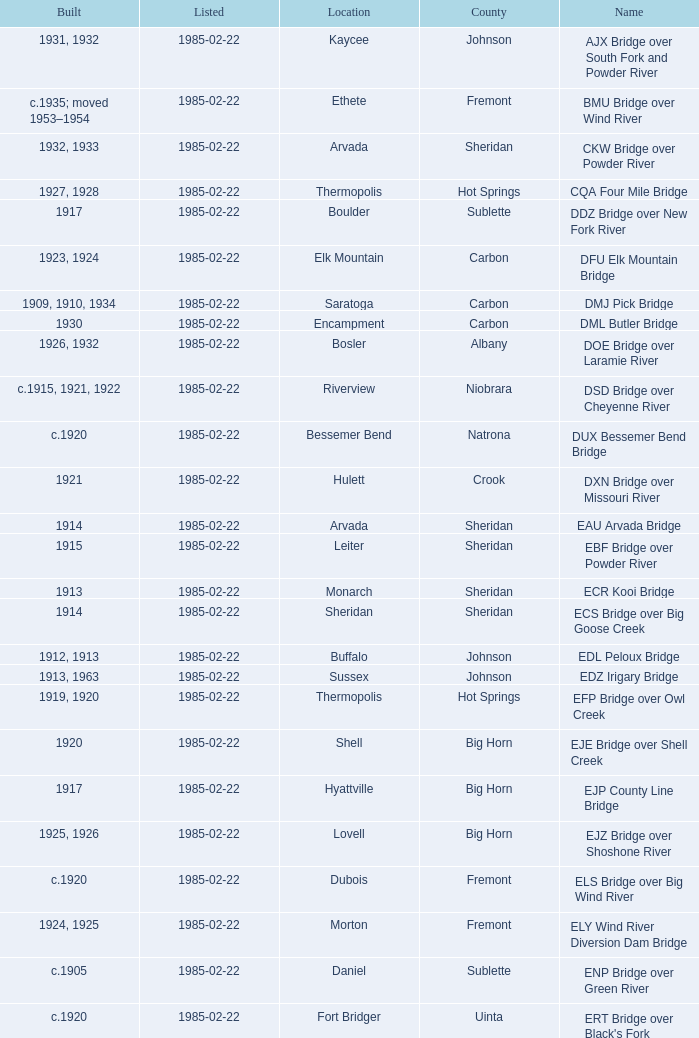What bridge in Sheridan county was built in 1915? EBF Bridge over Powder River. 